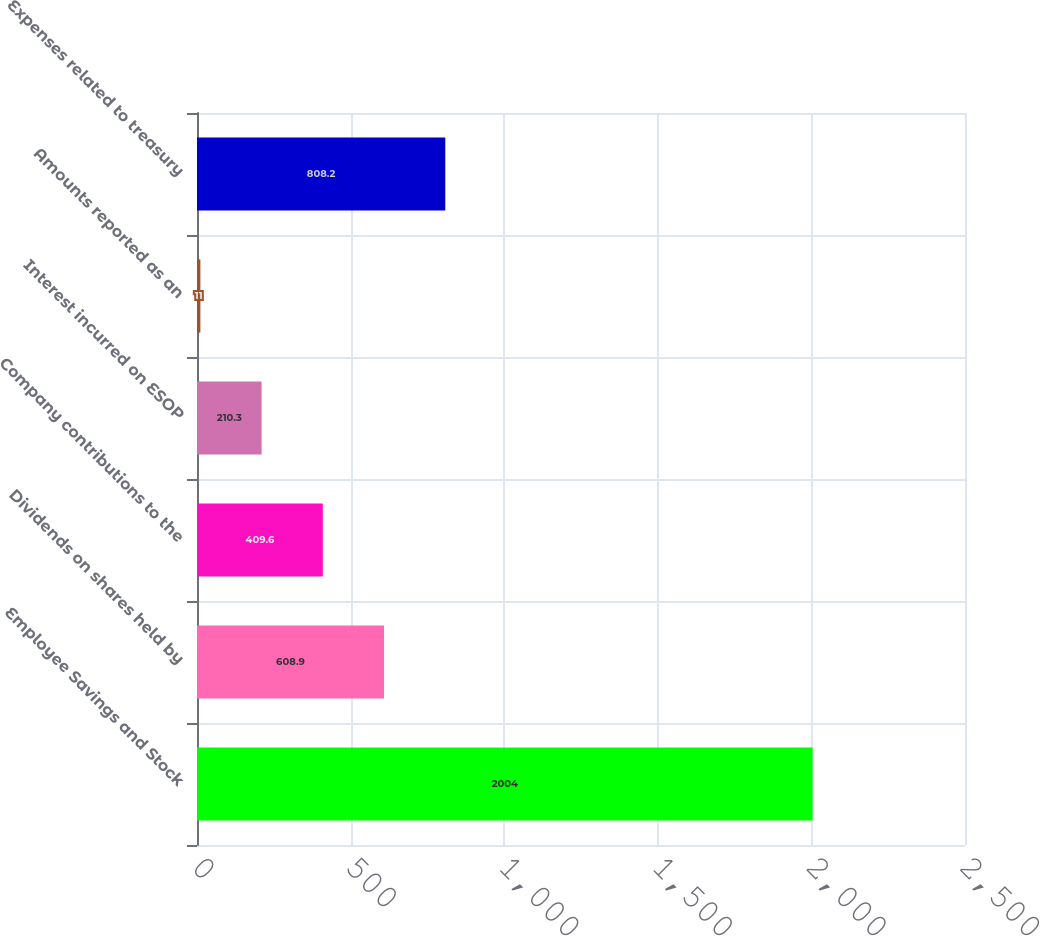<chart> <loc_0><loc_0><loc_500><loc_500><bar_chart><fcel>Employee Savings and Stock<fcel>Dividends on shares held by<fcel>Company contributions to the<fcel>Interest incurred on ESOP<fcel>Amounts reported as an<fcel>Expenses related to treasury<nl><fcel>2004<fcel>608.9<fcel>409.6<fcel>210.3<fcel>11<fcel>808.2<nl></chart> 